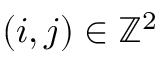<formula> <loc_0><loc_0><loc_500><loc_500>( i , j ) \in \mathbb { Z } ^ { 2 }</formula> 